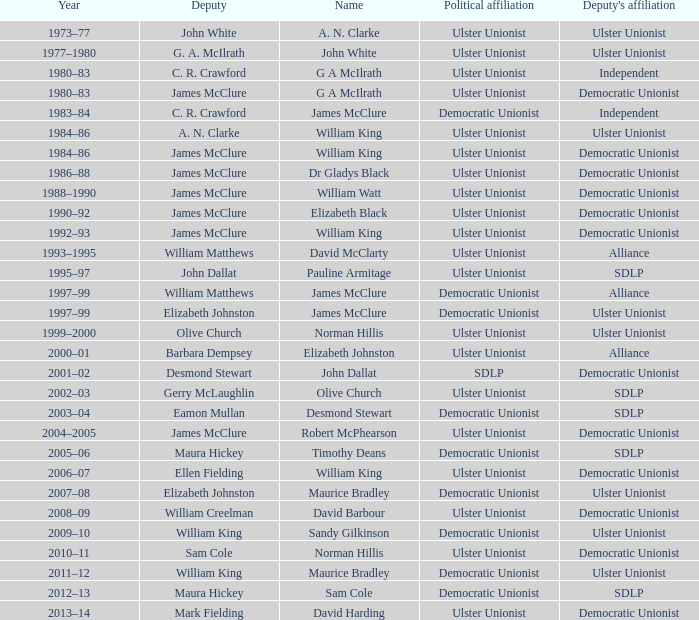What year did james mcclure hold the position of deputy, and the individual's name is robert mcphearson? 2004–2005. 